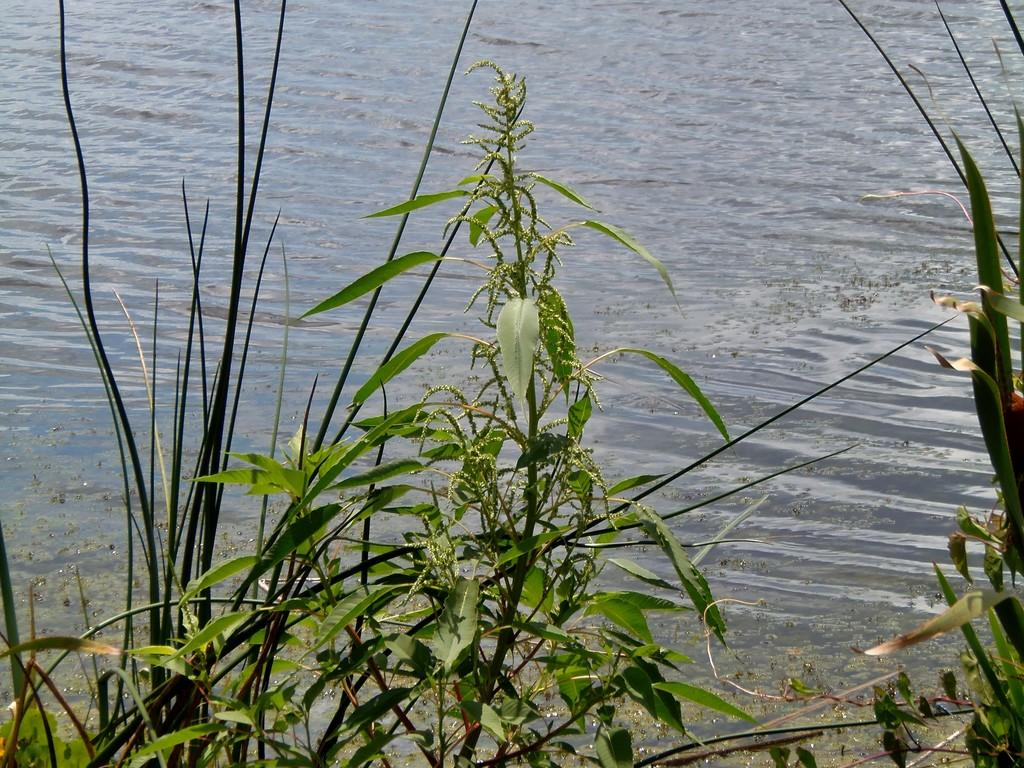What is the possible location from where the image was taken? The image might be taken from outside of the city. What type of natural elements can be seen in the image? There are plants and trees in the image. What body of water is visible in the background of the image? There is a lake visible in the background of the image. How many rings are visible on the mouth of the person in the image? There is no person present in the image, and therefore no mouth or rings can be observed. 